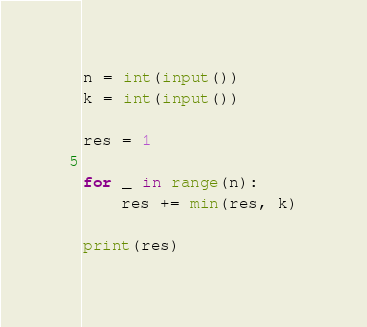<code> <loc_0><loc_0><loc_500><loc_500><_Python_>n = int(input())
k = int(input())

res = 1

for _ in range(n):
    res += min(res, k)

print(res)
</code> 